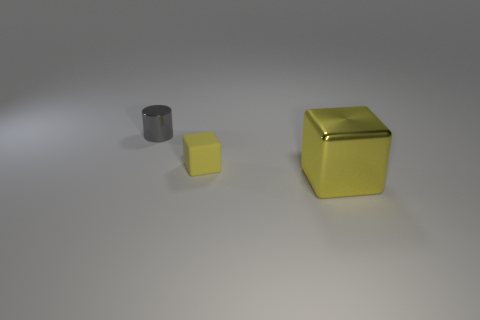Are there fewer yellow metallic objects on the left side of the gray cylinder than shiny cylinders that are on the right side of the big object?
Your answer should be compact. No. What number of cubes are made of the same material as the large object?
Your response must be concise. 0. There is a gray cylinder; is it the same size as the metal object that is right of the small gray thing?
Offer a very short reply. No. There is another block that is the same color as the big block; what is its material?
Provide a short and direct response. Rubber. There is a yellow thing that is to the left of the yellow cube on the right side of the yellow object that is behind the large object; how big is it?
Your answer should be compact. Small. Is the number of gray things to the right of the tiny metallic cylinder greater than the number of yellow shiny cubes to the right of the large yellow shiny thing?
Keep it short and to the point. No. There is a metal thing that is to the right of the yellow matte object; how many yellow metallic blocks are on the left side of it?
Make the answer very short. 0. Are there any other metal cubes of the same color as the big block?
Give a very brief answer. No. Do the matte object and the cylinder have the same size?
Keep it short and to the point. Yes. Do the metal cube and the metal cylinder have the same color?
Make the answer very short. No. 